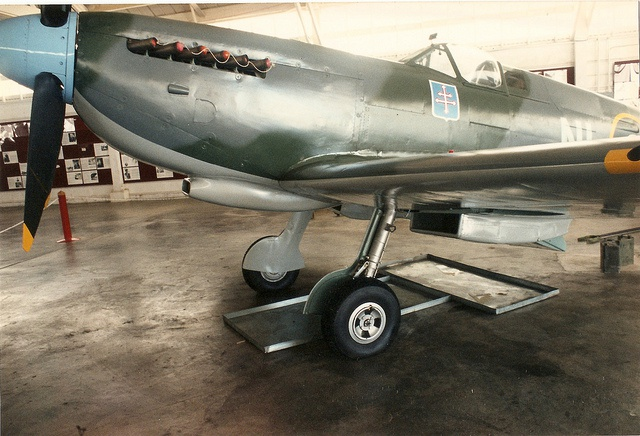Describe the objects in this image and their specific colors. I can see a airplane in white, gray, darkgray, black, and beige tones in this image. 